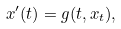Convert formula to latex. <formula><loc_0><loc_0><loc_500><loc_500>x ^ { \prime } ( t ) = g ( t , x _ { t } ) ,</formula> 